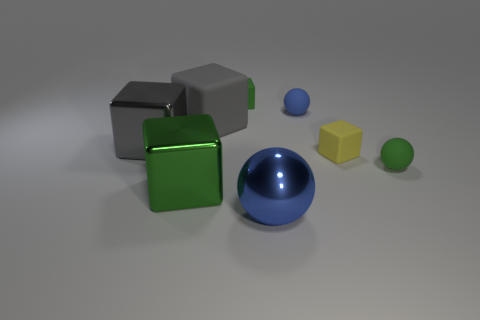Is the number of big things that are behind the green metal thing greater than the number of gray objects in front of the blue metallic object?
Your answer should be very brief. Yes. How many large blue shiny balls are to the left of the small green matte object that is in front of the small green cube?
Keep it short and to the point. 1. What number of things are either green rubber balls or green matte blocks?
Your answer should be very brief. 2. Do the large blue object and the gray shiny object have the same shape?
Make the answer very short. No. What is the material of the tiny blue thing?
Ensure brevity in your answer.  Rubber. What number of green things are both in front of the tiny yellow rubber block and right of the big green cube?
Offer a very short reply. 1. Do the green ball and the yellow rubber thing have the same size?
Provide a succinct answer. Yes. There is a blue rubber sphere that is behind the yellow thing; is its size the same as the big blue object?
Your answer should be compact. No. What is the color of the matte block that is on the right side of the blue matte object?
Your answer should be compact. Yellow. How many gray things are there?
Give a very brief answer. 2. 